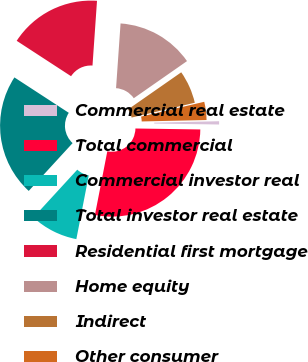Convert chart to OTSL. <chart><loc_0><loc_0><loc_500><loc_500><pie_chart><fcel>Commercial real estate<fcel>Total commercial<fcel>Commercial investor real<fcel>Total investor real estate<fcel>Residential first mortgage<fcel>Home equity<fcel>Indirect<fcel>Other consumer<nl><fcel>0.59%<fcel>27.82%<fcel>8.76%<fcel>22.37%<fcel>16.92%<fcel>14.2%<fcel>6.03%<fcel>3.31%<nl></chart> 